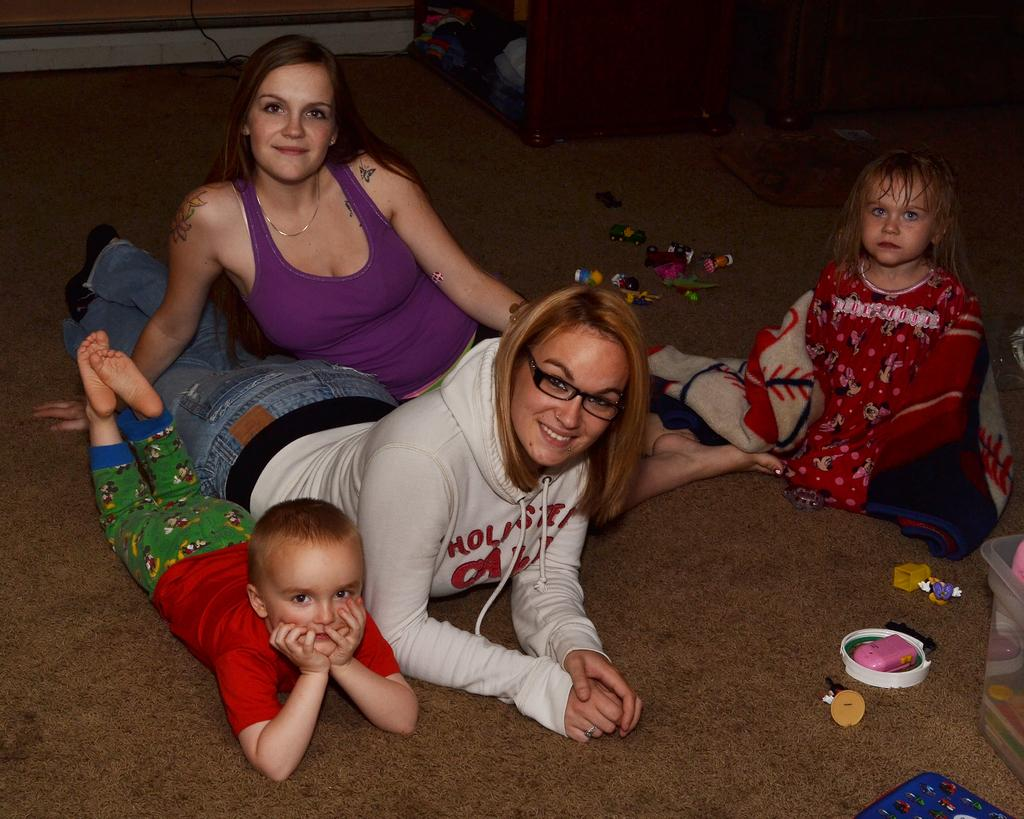Who is present in the image? There are women and children in the image. What are the women and children doing in the image? The women and children are lying on the floor. What else can be seen on the floor in the image? There are toys on the floor in the image. What is the background object in the image? There is a cupboard in the image. How many times does the woman sneeze in the image? There is no indication of anyone sneezing in the image. What type of collar is the child wearing in the image? There is no mention of any collars in the image; the children are not wearing any visible clothing items that would include a collar. 